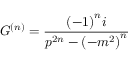Convert formula to latex. <formula><loc_0><loc_0><loc_500><loc_500>G ^ { \left ( n \right ) } = \frac { { \left ( - 1 \right ) } ^ { n } i } { p ^ { 2 n } - { \left ( - m ^ { 2 } \right ) } ^ { n } }</formula> 